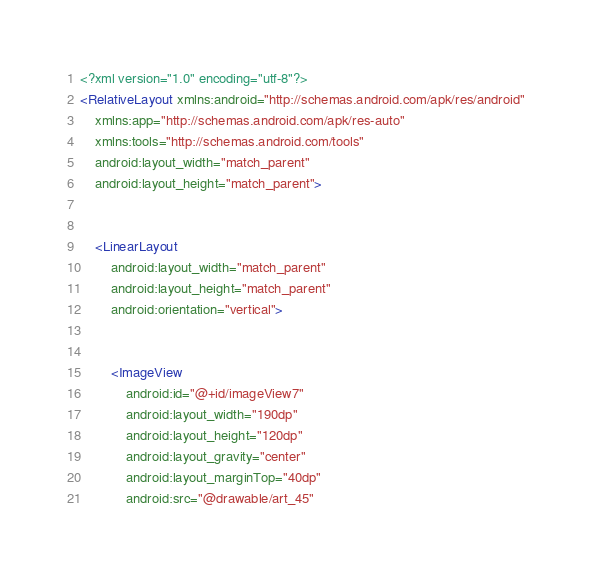Convert code to text. <code><loc_0><loc_0><loc_500><loc_500><_XML_><?xml version="1.0" encoding="utf-8"?>
<RelativeLayout xmlns:android="http://schemas.android.com/apk/res/android"
    xmlns:app="http://schemas.android.com/apk/res-auto"
    xmlns:tools="http://schemas.android.com/tools"
    android:layout_width="match_parent"
    android:layout_height="match_parent">


    <LinearLayout
        android:layout_width="match_parent"
        android:layout_height="match_parent"
        android:orientation="vertical">


        <ImageView
            android:id="@+id/imageView7"
            android:layout_width="190dp"
            android:layout_height="120dp"
            android:layout_gravity="center"
            android:layout_marginTop="40dp"
            android:src="@drawable/art_45"</code> 